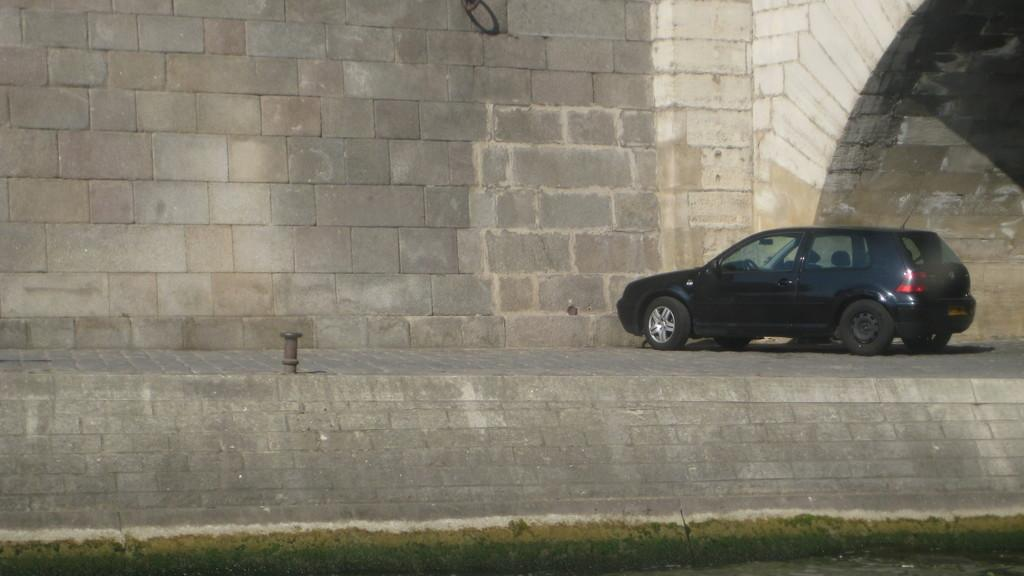What type of vehicle is parked on the right side of the image? There is a car parked on the right side of the image. What can be seen on the left side of the image? There is a stone wall on the left side of the image. What type of book is the dog reading in the image? There is no dog or book present in the image. 